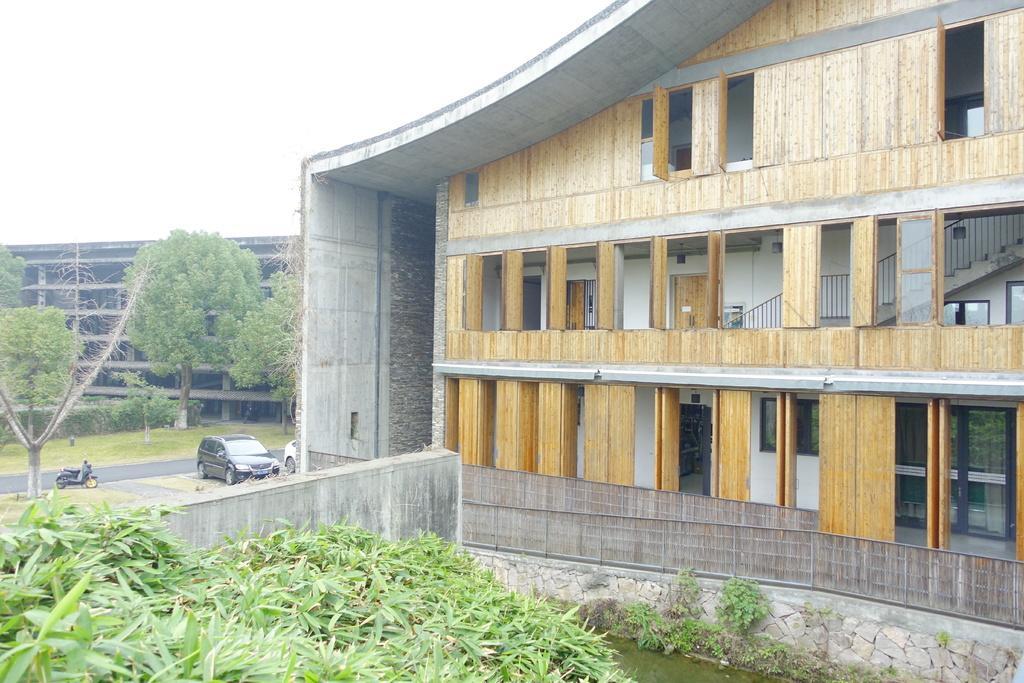Describe this image in one or two sentences. In the picture we can see a part of the plant and near it, we can see a water and a wall and behind it, we can see a building with wooden planks and doors to it and inside the building we can see two cars and a bike are parked and opposite side of it we can see a grass surface and on it we can see a construction building and the sky behind it. 